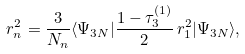<formula> <loc_0><loc_0><loc_500><loc_500>r _ { n } ^ { 2 } = \frac { 3 } { N _ { n } } \langle \Psi _ { 3 N } | \frac { 1 - \tau _ { 3 } ^ { ( 1 ) } } { 2 } \, r _ { 1 } ^ { 2 } | \Psi _ { 3 N } \rangle ,</formula> 